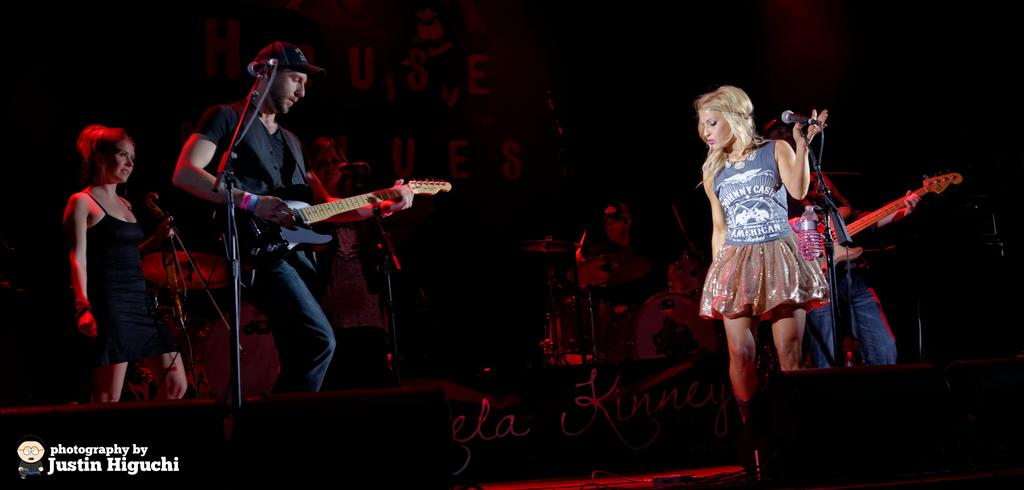What are the people in the image doing? The persons in the image are standing in front of a microphone. What is one person doing specifically? One person is playing a guitar. Can you describe the appearance of the person playing the guitar? The person playing the guitar is wearing a cap. What else can be seen in the background of the image? There are musical instruments in the background. What achievement is the person wearing the cap celebrating in the image? There is no indication in the image that the person wearing the cap is celebrating any achievement. Can you tell me how many copies of the guitar are visible in the image? There is only one guitar visible in the image, and it is being played by the person wearing the cap. 